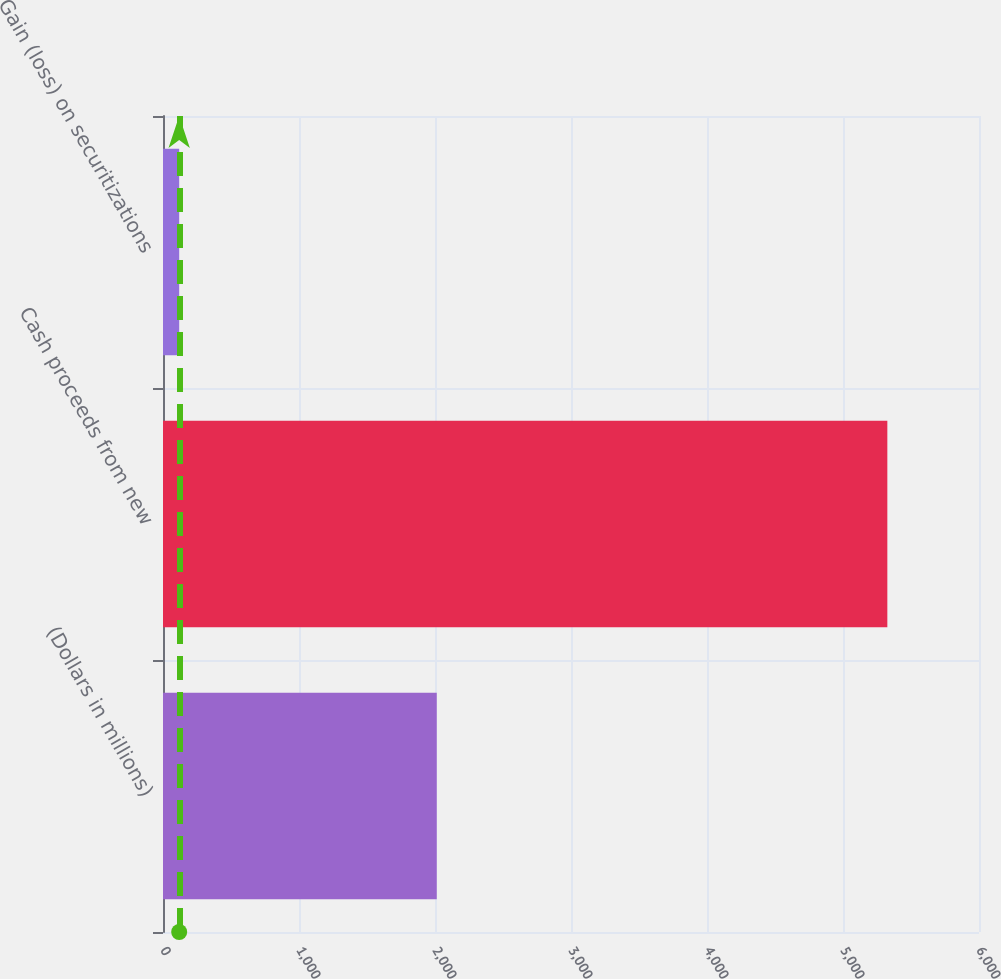Convert chart. <chart><loc_0><loc_0><loc_500><loc_500><bar_chart><fcel>(Dollars in millions)<fcel>Cash proceeds from new<fcel>Gain (loss) on securitizations<nl><fcel>2013<fcel>5326<fcel>119<nl></chart> 